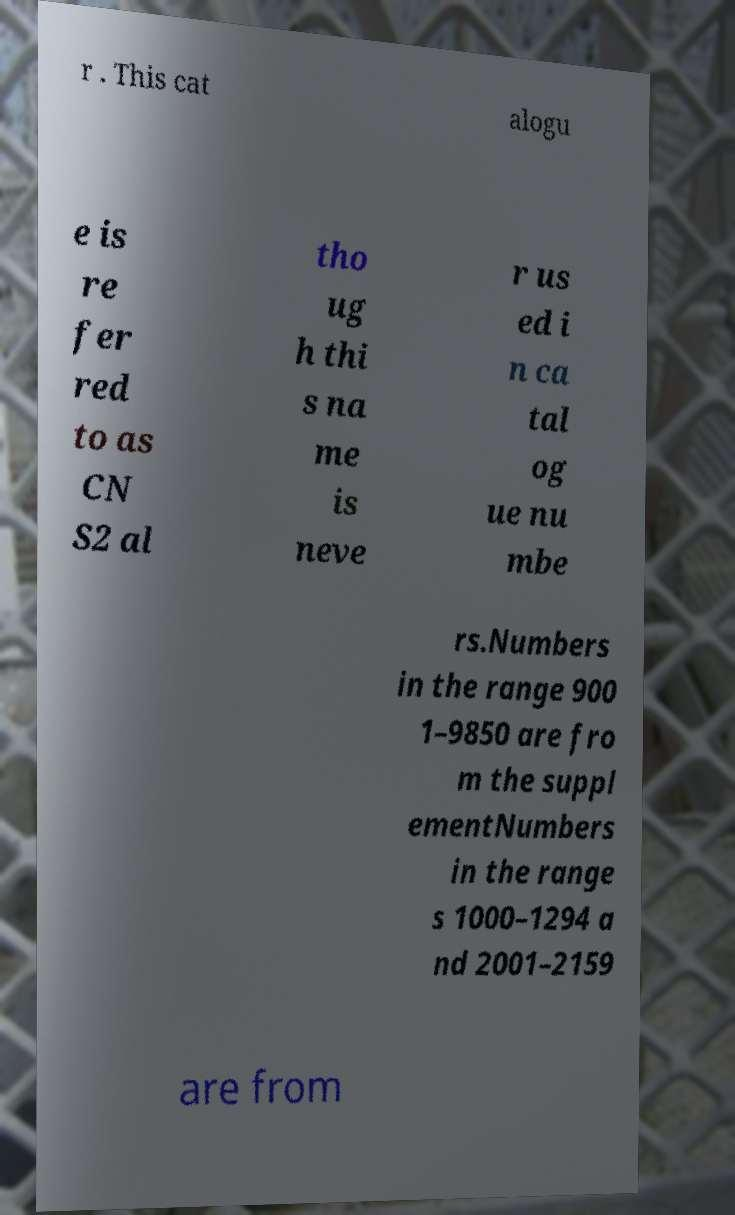What messages or text are displayed in this image? I need them in a readable, typed format. r . This cat alogu e is re fer red to as CN S2 al tho ug h thi s na me is neve r us ed i n ca tal og ue nu mbe rs.Numbers in the range 900 1–9850 are fro m the suppl ementNumbers in the range s 1000–1294 a nd 2001–2159 are from 